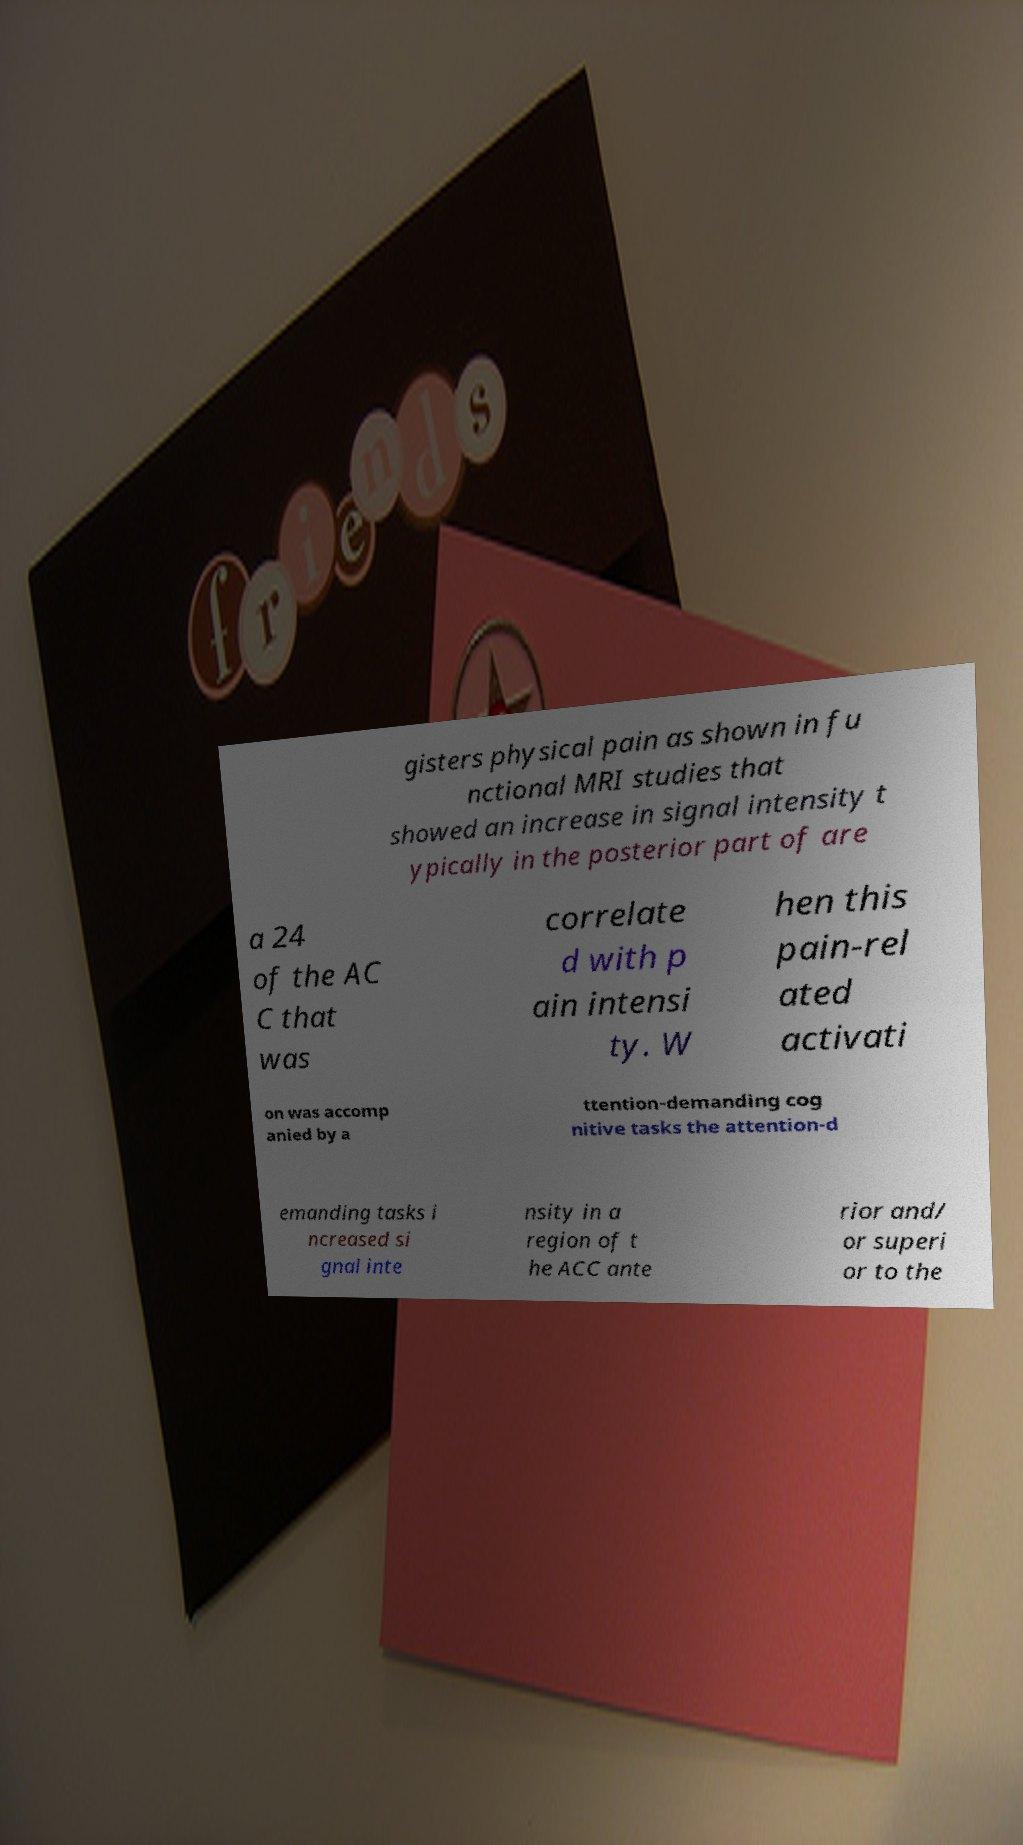Can you accurately transcribe the text from the provided image for me? gisters physical pain as shown in fu nctional MRI studies that showed an increase in signal intensity t ypically in the posterior part of are a 24 of the AC C that was correlate d with p ain intensi ty. W hen this pain-rel ated activati on was accomp anied by a ttention-demanding cog nitive tasks the attention-d emanding tasks i ncreased si gnal inte nsity in a region of t he ACC ante rior and/ or superi or to the 